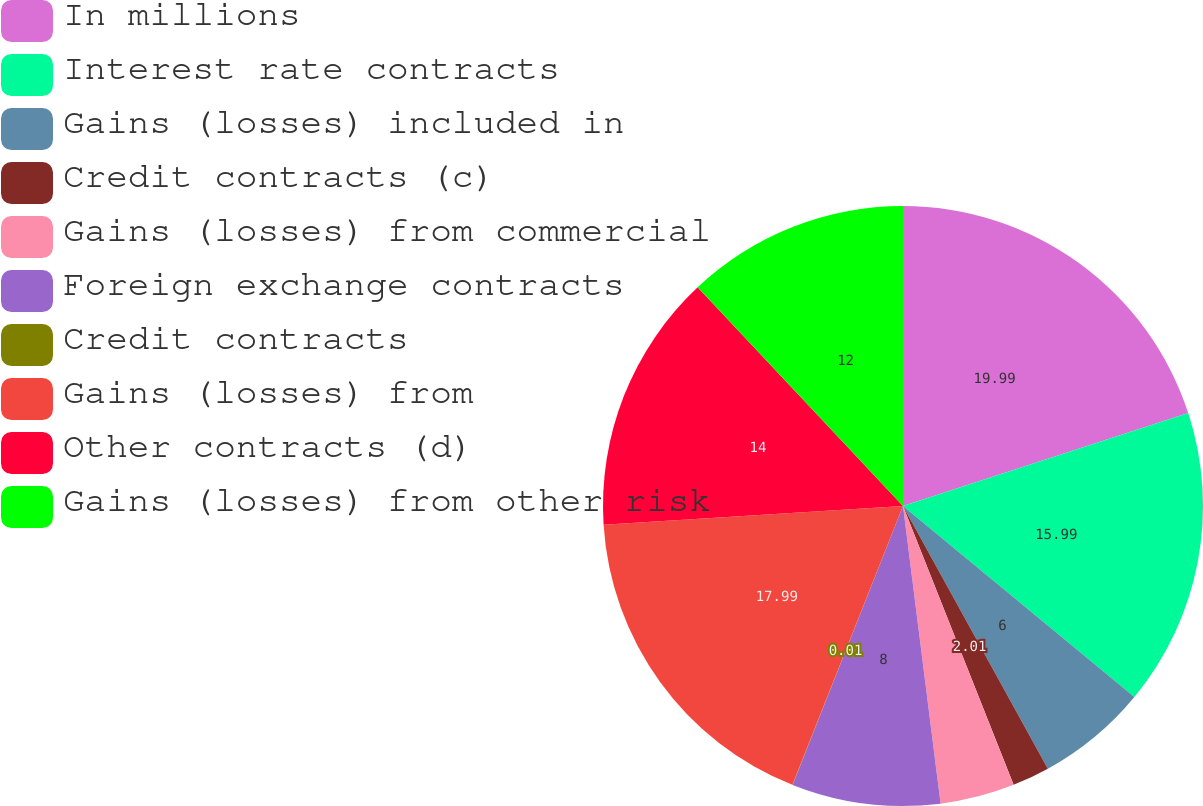Convert chart. <chart><loc_0><loc_0><loc_500><loc_500><pie_chart><fcel>In millions<fcel>Interest rate contracts<fcel>Gains (losses) included in<fcel>Credit contracts (c)<fcel>Gains (losses) from commercial<fcel>Foreign exchange contracts<fcel>Credit contracts<fcel>Gains (losses) from<fcel>Other contracts (d)<fcel>Gains (losses) from other risk<nl><fcel>19.99%<fcel>15.99%<fcel>6.0%<fcel>2.01%<fcel>4.01%<fcel>8.0%<fcel>0.01%<fcel>17.99%<fcel>14.0%<fcel>12.0%<nl></chart> 